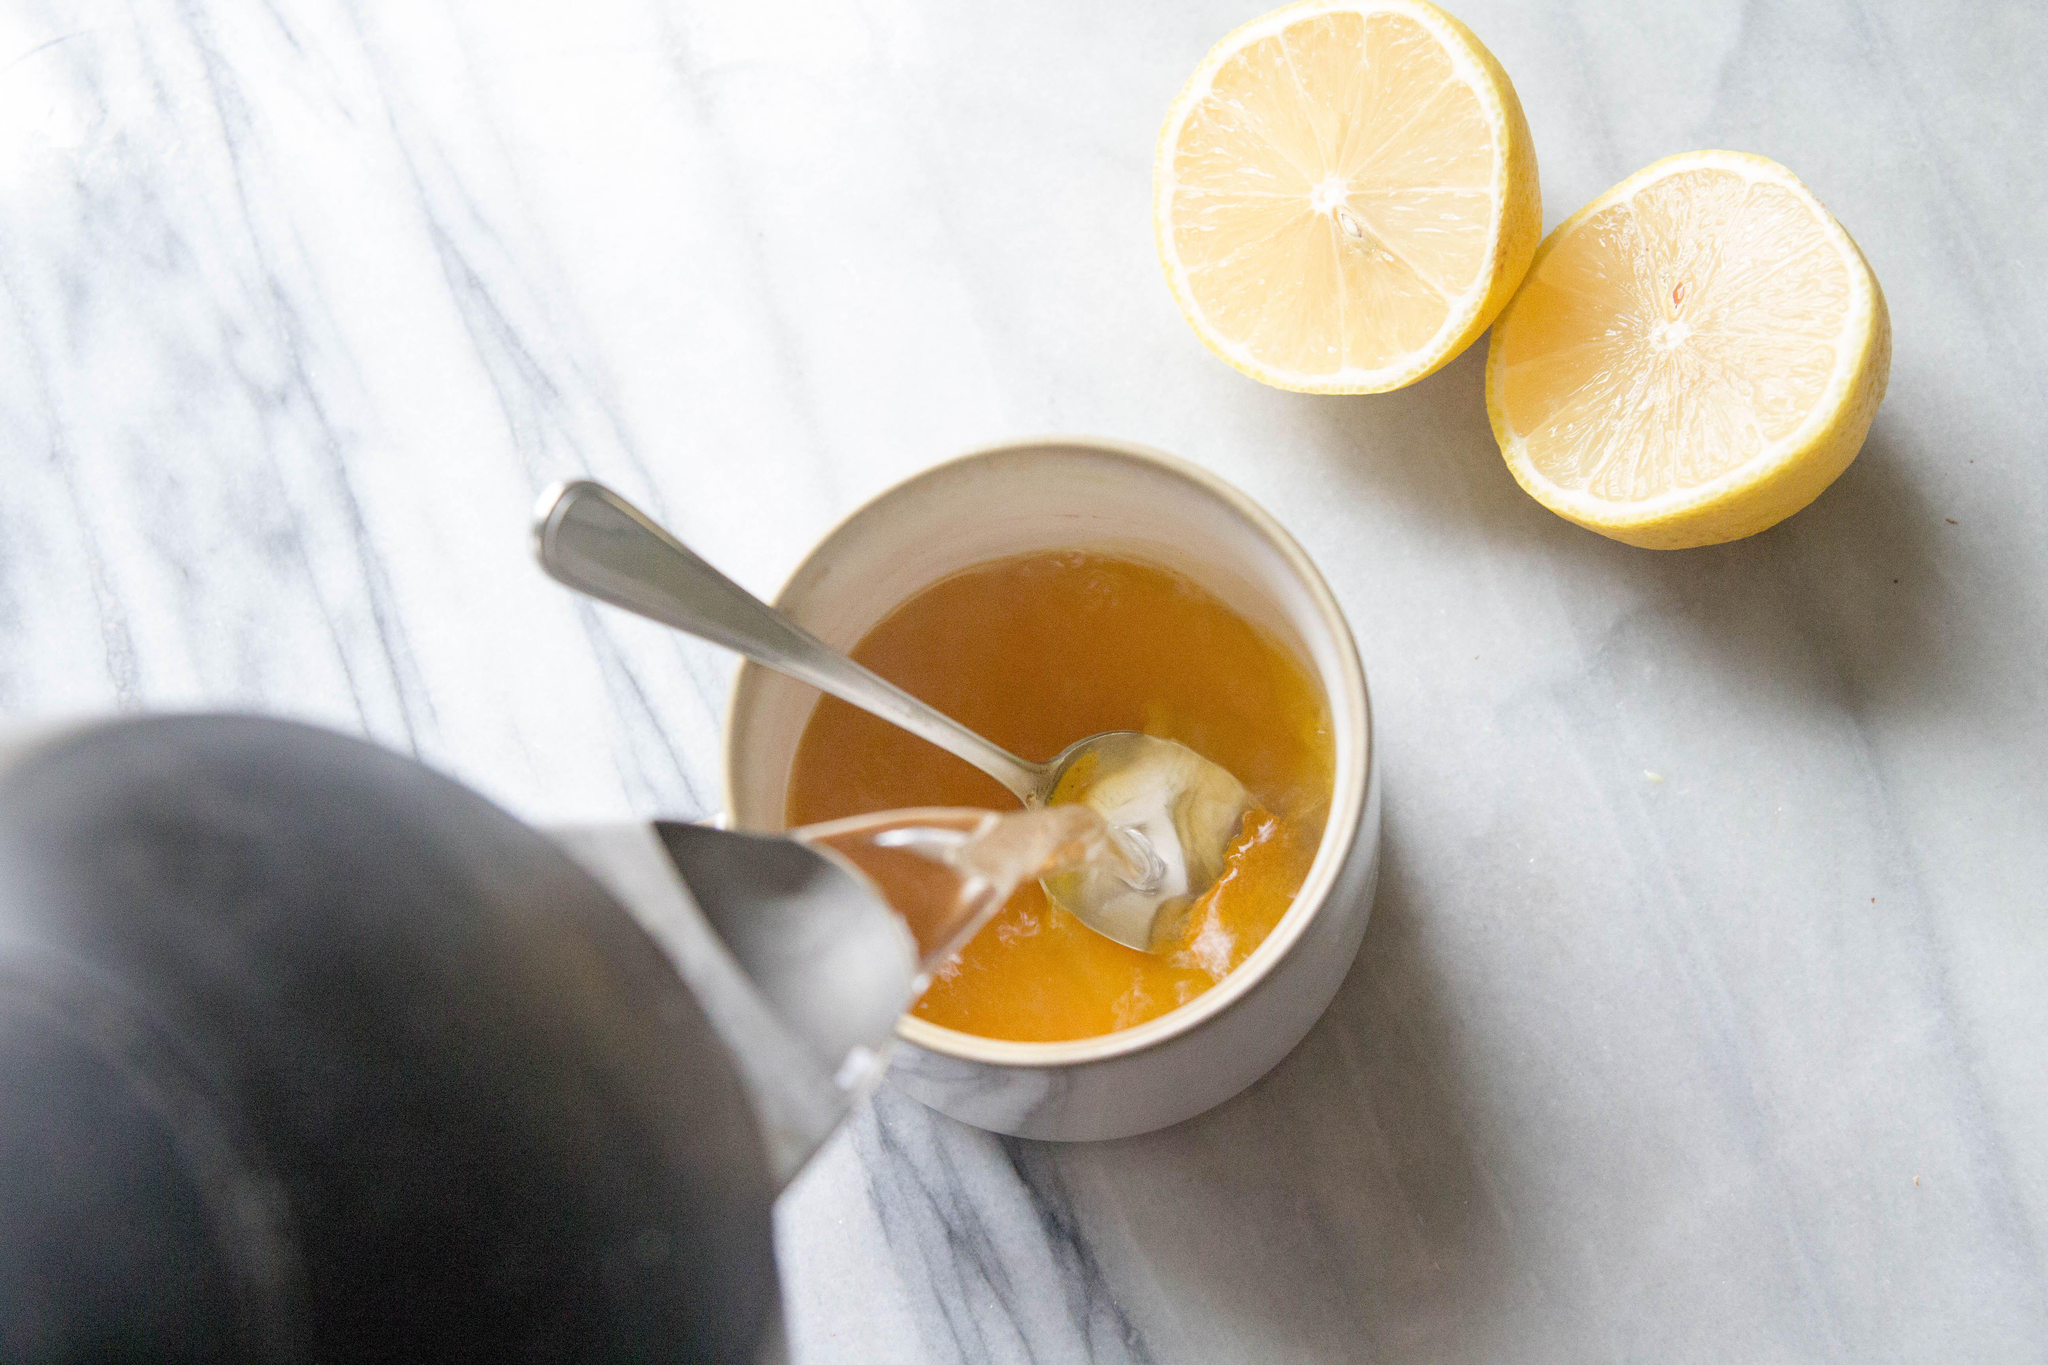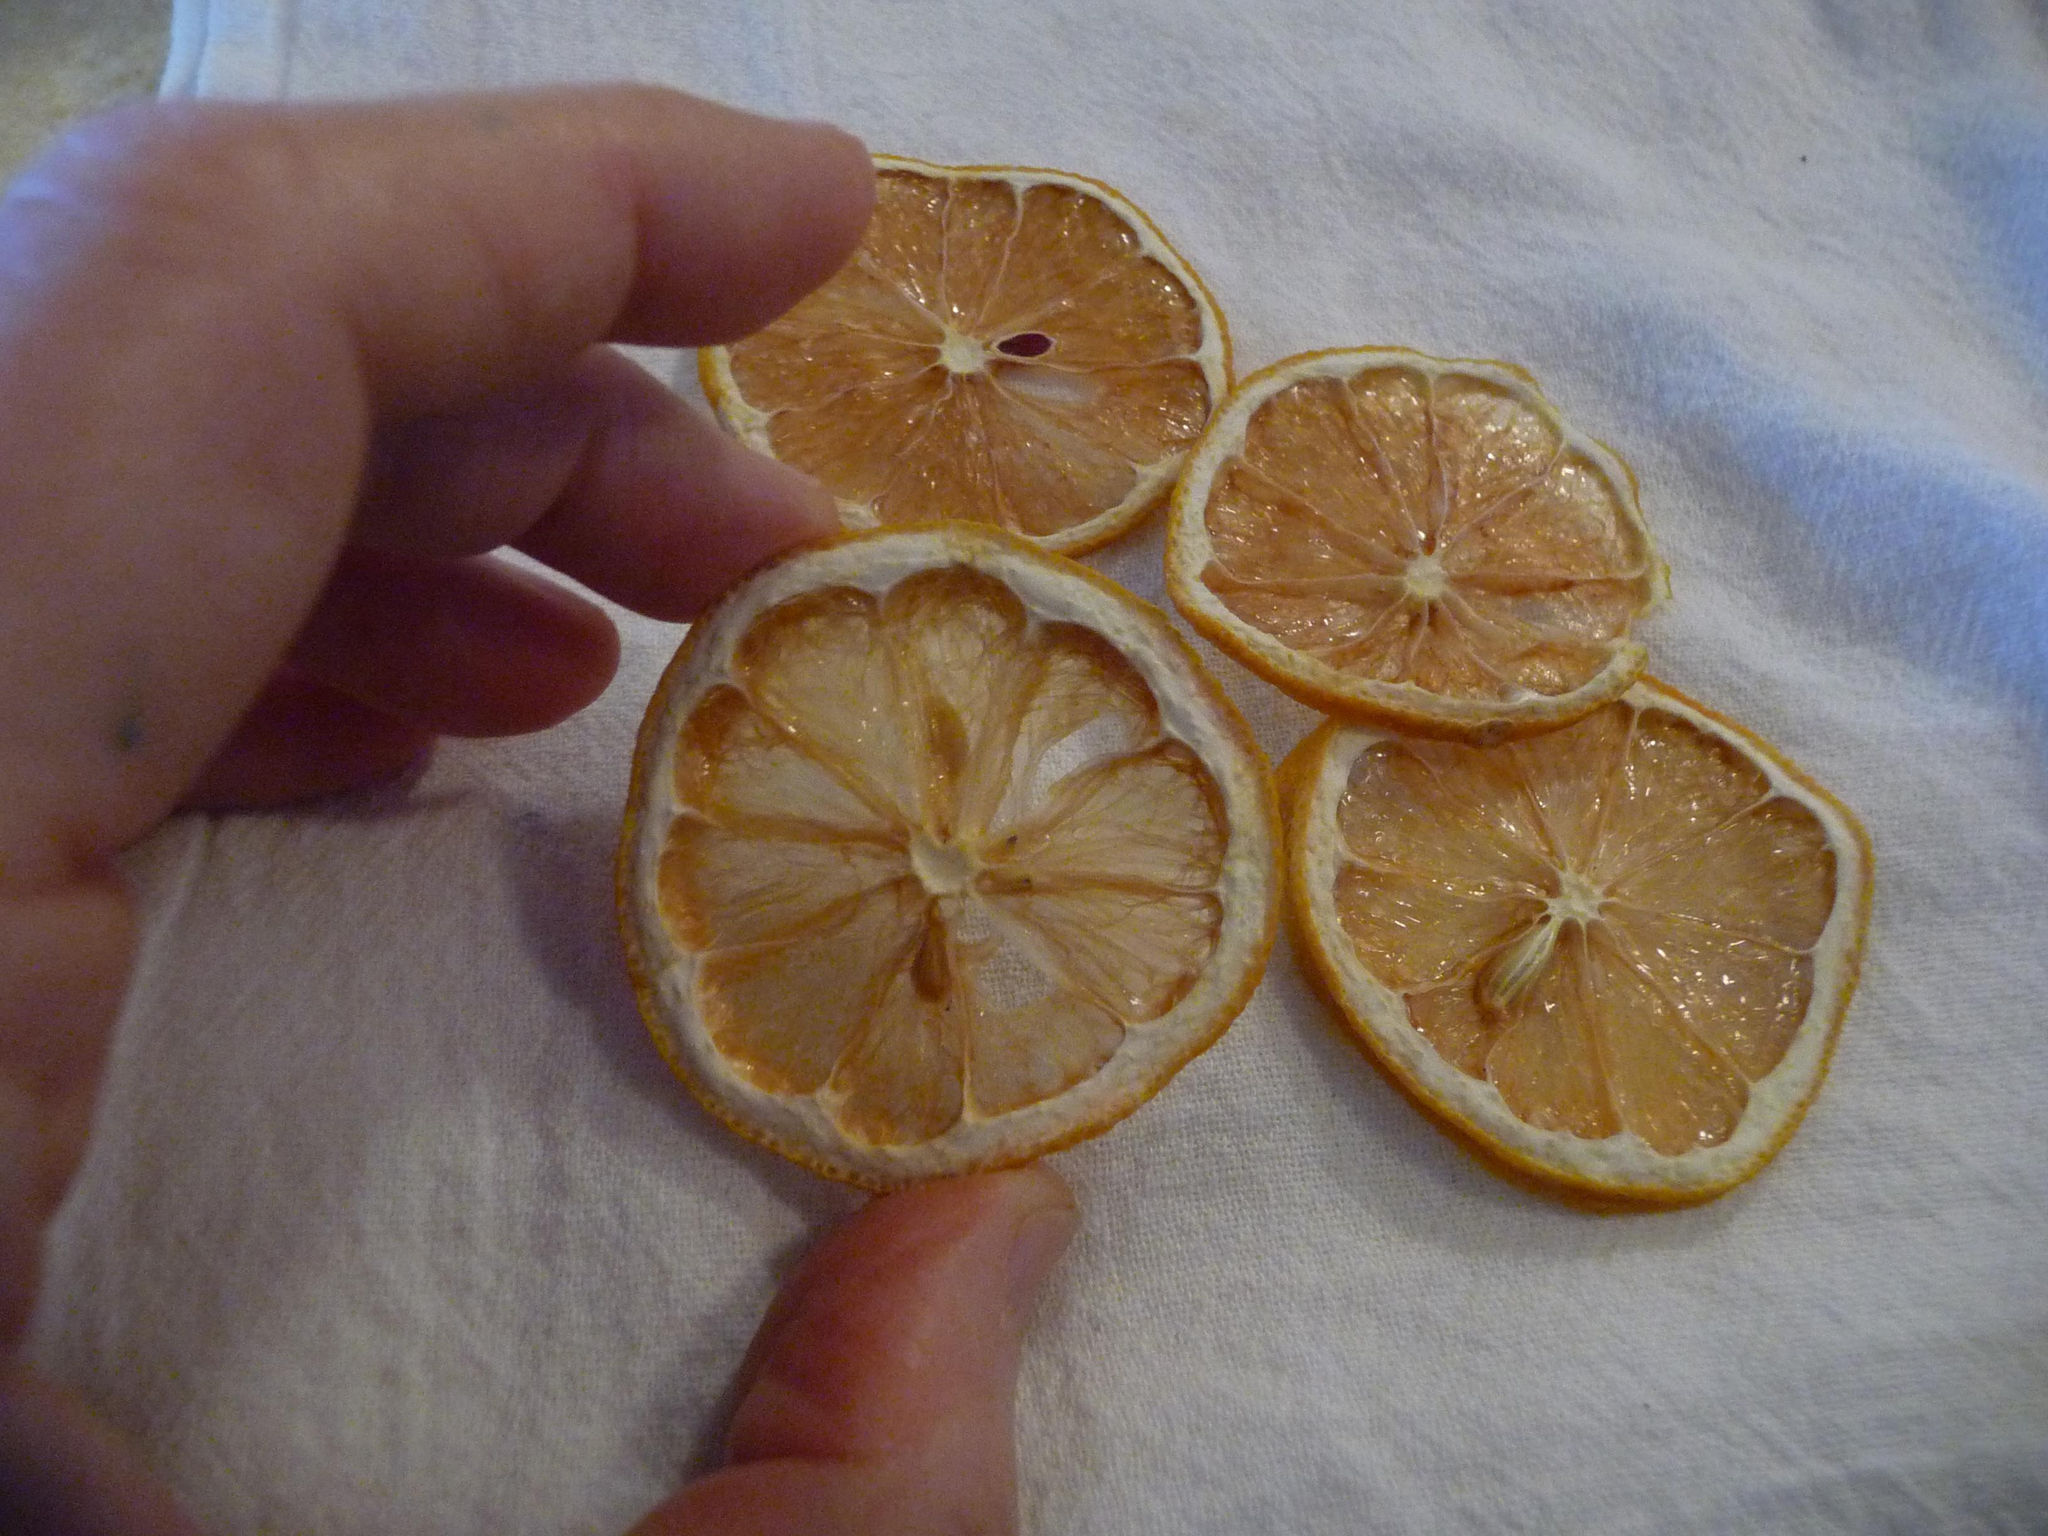The first image is the image on the left, the second image is the image on the right. Considering the images on both sides, is "In at least one image there are two halves of a lemon." valid? Answer yes or no. Yes. 